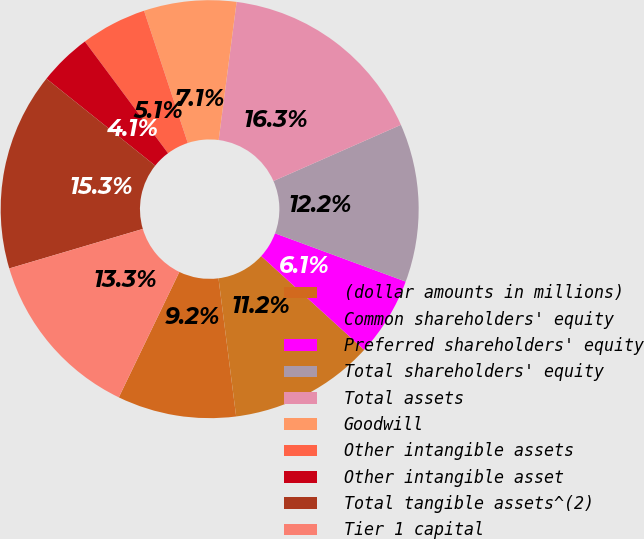<chart> <loc_0><loc_0><loc_500><loc_500><pie_chart><fcel>(dollar amounts in millions)<fcel>Common shareholders' equity<fcel>Preferred shareholders' equity<fcel>Total shareholders' equity<fcel>Total assets<fcel>Goodwill<fcel>Other intangible assets<fcel>Other intangible asset<fcel>Total tangible assets^(2)<fcel>Tier 1 capital<nl><fcel>9.18%<fcel>11.22%<fcel>6.12%<fcel>12.24%<fcel>16.33%<fcel>7.14%<fcel>5.1%<fcel>4.08%<fcel>15.31%<fcel>13.26%<nl></chart> 